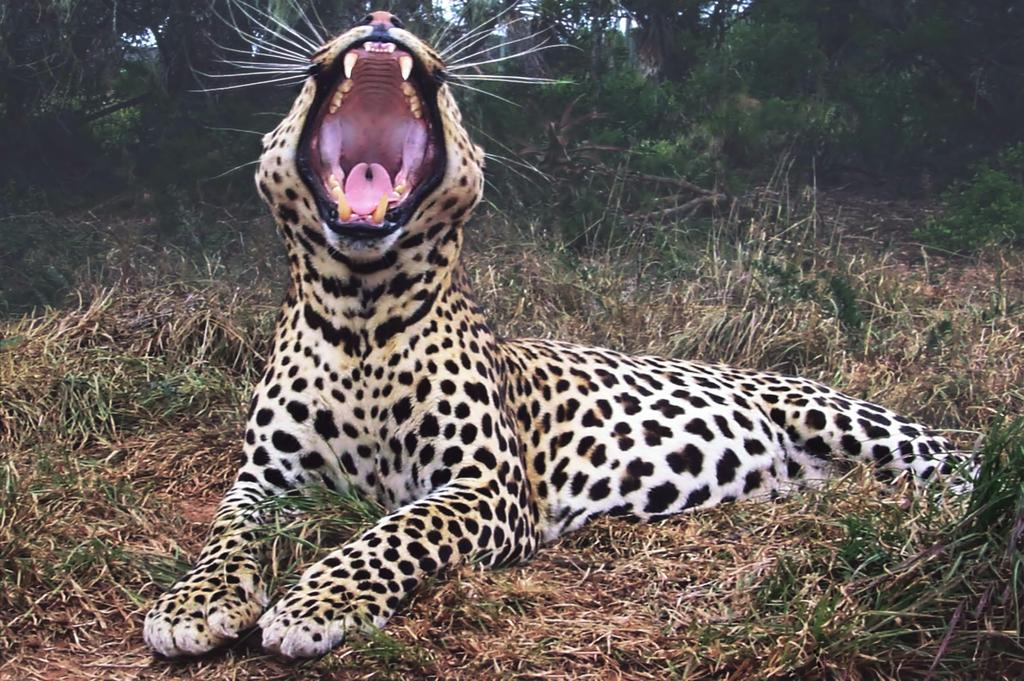What animal is in the image? There is a tiger in the image. What position is the tiger in? The tiger is sitting on the ground. What is the tiger doing with its mouth? The tiger has its mouth open. What can be seen in the background of the image? There are trees in the background of the image. What type of vegetation is on the ground in the image? There is grass on the ground in the image. How many beggars are present in the image? There are no beggars present in the image; it features a tiger sitting on the ground. What type of spiders can be seen crawling on the tiger's fur in the image? There are no spiders present in the image; it features a tiger sitting on the ground with its mouth open. 